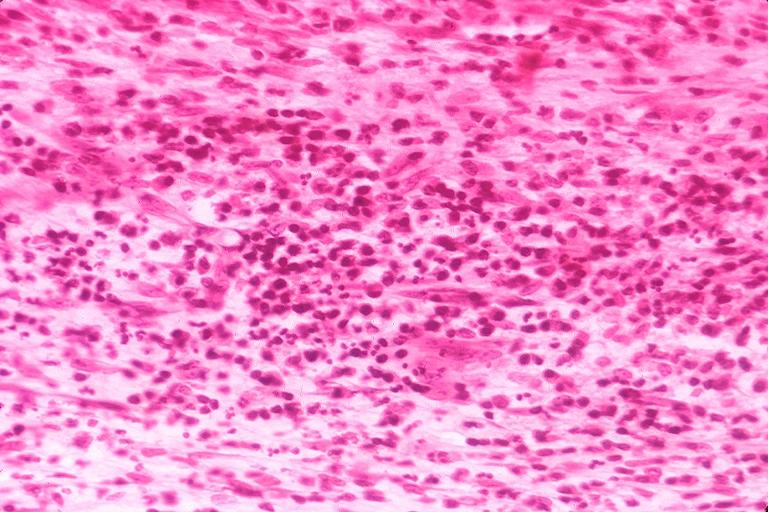what is present?
Answer the question using a single word or phrase. Oral 